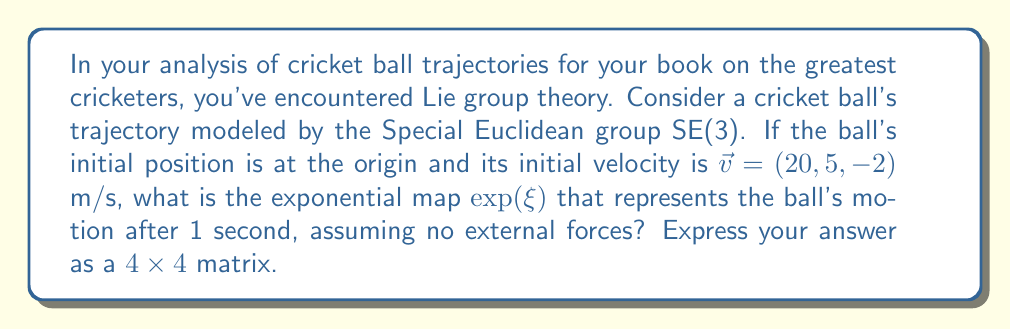Solve this math problem. To solve this problem, we'll use the theory of Lie groups and their application to rigid body motion, which is relevant to analyzing cricket ball trajectories.

1) The Special Euclidean group SE(3) represents rigid body motions in 3D space, combining rotations and translations.

2) In this case, we have pure translation (no rotation), so our twist $\xi$ will only have a translational component.

3) The twist $\xi$ is represented as:

   $$\xi = \begin{pmatrix} 0 & 0 & 0 & v_x \\ 0 & 0 & 0 & v_y \\ 0 & 0 & 0 & v_z \\ 0 & 0 & 0 & 0 \end{pmatrix}$$

   where $(v_x, v_y, v_z)$ is the velocity vector.

4) Given $\vec{v} = (20, 5, -2)$ m/s, our twist is:

   $$\xi = \begin{pmatrix} 0 & 0 & 0 & 20 \\ 0 & 0 & 0 & 5 \\ 0 & 0 & 0 & -2 \\ 0 & 0 & 0 & 0 \end{pmatrix}$$

5) The exponential map for a pure translation is given by:

   $$\exp(\xi) = I + \xi$$

   where $I$ is the $4 \times 4$ identity matrix.

6) Calculating $\exp(\xi)$:

   $$\exp(\xi) = \begin{pmatrix} 1 & 0 & 0 & 0 \\ 0 & 1 & 0 & 0 \\ 0 & 0 & 1 & 0 \\ 0 & 0 & 0 & 1 \end{pmatrix} + \begin{pmatrix} 0 & 0 & 0 & 20 \\ 0 & 0 & 0 & 5 \\ 0 & 0 & 0 & -2 \\ 0 & 0 & 0 & 0 \end{pmatrix}$$

7) This gives us the final result:

   $$\exp(\xi) = \begin{pmatrix} 1 & 0 & 0 & 20 \\ 0 & 1 & 0 & 5 \\ 0 & 0 & 1 & -2 \\ 0 & 0 & 0 & 1 \end{pmatrix}$$

This matrix represents the transformation of the ball's position after 1 second of motion.
Answer: $$\exp(\xi) = \begin{pmatrix} 1 & 0 & 0 & 20 \\ 0 & 1 & 0 & 5 \\ 0 & 0 & 1 & -2 \\ 0 & 0 & 0 & 1 \end{pmatrix}$$ 